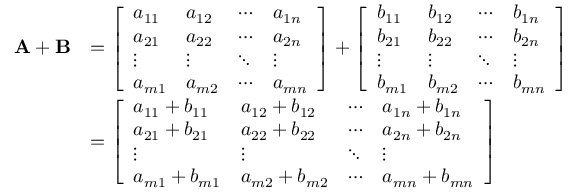<formula> <loc_0><loc_0><loc_500><loc_500>{ \begin{array} { r l } { A + B } & { = { \left [ \begin{array} { l l l l } { a _ { 1 1 } } & { a _ { 1 2 } } & { \cdots } & { a _ { 1 n } } \\ { a _ { 2 1 } } & { a _ { 2 2 } } & { \cdots } & { a _ { 2 n } } \\ { \vdots } & { \vdots } & { \ddots } & { \vdots } \\ { a _ { m 1 } } & { a _ { m 2 } } & { \cdots } & { a _ { m n } } \end{array} \right ] } + { \left [ \begin{array} { l l l l } { b _ { 1 1 } } & { b _ { 1 2 } } & { \cdots } & { b _ { 1 n } } \\ { b _ { 2 1 } } & { b _ { 2 2 } } & { \cdots } & { b _ { 2 n } } \\ { \vdots } & { \vdots } & { \ddots } & { \vdots } \\ { b _ { m 1 } } & { b _ { m 2 } } & { \cdots } & { b _ { m n } } \end{array} \right ] } } \\ & { = { \left [ \begin{array} { l l l l } { a _ { 1 1 } + b _ { 1 1 } } & { a _ { 1 2 } + b _ { 1 2 } } & { \cdots } & { a _ { 1 n } + b _ { 1 n } } \\ { a _ { 2 1 } + b _ { 2 1 } } & { a _ { 2 2 } + b _ { 2 2 } } & { \cdots } & { a _ { 2 n } + b _ { 2 n } } \\ { \vdots } & { \vdots } & { \ddots } & { \vdots } \\ { a _ { m 1 } + b _ { m 1 } } & { a _ { m 2 } + b _ { m 2 } } & { \cdots } & { a _ { m n } + b _ { m n } } \end{array} \right ] } } \end{array} }</formula> 